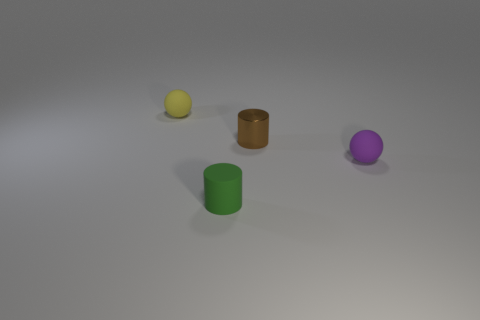How big is the thing that is on the right side of the yellow sphere and behind the purple matte object?
Your answer should be compact. Small. Are there fewer brown shiny things behind the small green cylinder than tiny green matte spheres?
Offer a very short reply. No. Does the green thing have the same material as the brown cylinder?
Keep it short and to the point. No. What number of objects are either gray metal objects or tiny purple rubber balls?
Provide a succinct answer. 1. What number of cylinders are made of the same material as the small purple object?
Ensure brevity in your answer.  1. The other matte thing that is the same shape as the purple matte object is what size?
Make the answer very short. Small. There is a purple ball; are there any small yellow balls to the right of it?
Make the answer very short. No. What is the material of the brown thing?
Your answer should be compact. Metal. Is the color of the tiny ball that is to the right of the small yellow rubber sphere the same as the metal cylinder?
Provide a succinct answer. No. Is there anything else that has the same shape as the brown metallic object?
Your response must be concise. Yes. 